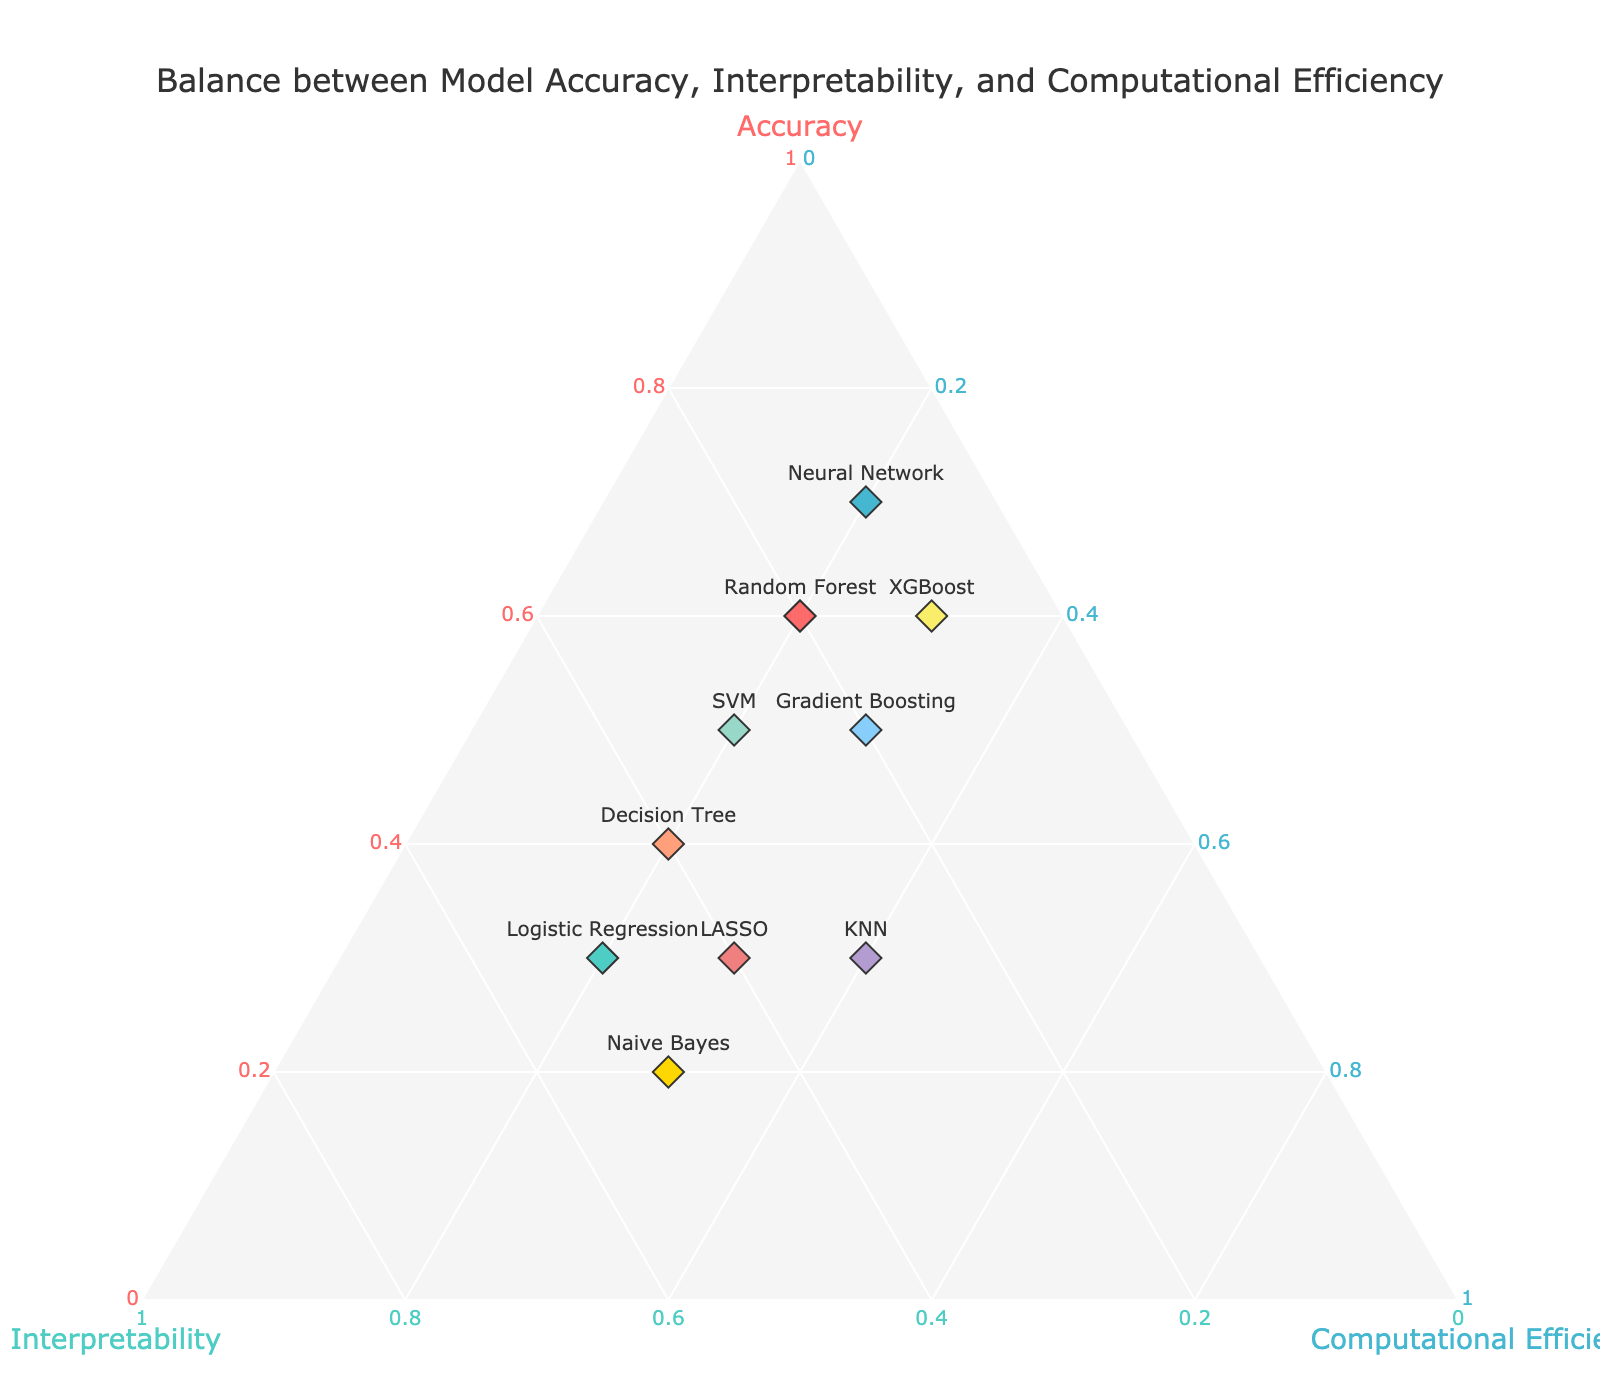What's the title of the plot? The title is usually located at the top center of the plot and gives a brief description of what the plot is showing. The title of this plot is "Balance between Model Accuracy, Interpretability, and Computational Efficiency".
Answer: Balance between Model Accuracy, Interpretability, and Computational Efficiency How many models are represented in the plot? The number of models can be counted by looking at the number of text labels on the plot. There are 10 models represented by different text labels in the plot.
Answer: 10 Which model has the highest accuracy? Accuracy values can be derived from the 'a' axis of the ternary plot, which is designated for accuracy. By checking the positions, we can see that the Neural Network model, with an accuracy of 0.7, has the highest accuracy among the models.
Answer: Neural Network Which model has better interpretability but lower accuracy compared to the Decision Tree? By looking at the labels and the positioning on the plot, any model that lies more along the 'b' axis for interpretability but less along the 'a' axis for accuracy than the Decision Tree can be identified. Logistic Regression and Naive Bayes meet these criteria.
Answer: Logistic Regression, Naive Bayes Among all models, which one shows the best balance between interpretability and computational efficiency? The balance can be evaluated by looking for the point that is closest to both interpretability (b-axis) and computational efficiency (c-axis). The model closest to balancing both highest interpretability and computational efficiency is Naive Bayes.
Answer: Naive Bayes Which models have the same computational efficiency? By analyzing the 'c' values on the ternary plot which represent computational efficiency, all models with a 'c' value of 0.2 can be determined. Random Forest, Logistic Regression, Neural Network, Decision Tree, and SVM all have the same computational efficiency of 0.2.
Answer: Random Forest, Logistic Regression, Neural Network, Decision Tree, SVM How does the interpretability of KNN compare to the interpretability of LASSO? Interpretability is represented along the 'b' axis. By comparing their 'b' values, we can see that both KNN and LASSO have the same interpretability value of 0.3 and 0.4 respectively.
Answer: LASSO is higher Which model is the most computationally efficient? The most computationally efficient model can be found by looking at the highest value along the 'c' axis. KNN has the highest 'c' value of 0.4.
Answer: KNN Which model shows a relatively balanced trade-off across all three metrics? A balanced trade-off can be inferred by looking for a model that does not have extreme values in any of the three axes. Gradient Boosting with 0.5 (accuracy), 0.2 (interpretability), and 0.3 (computational efficiency) shows a relatively balanced trade-off.
Answer: Gradient Boosting 